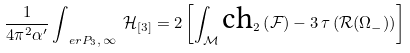Convert formula to latex. <formula><loc_0><loc_0><loc_500><loc_500>\frac { 1 } { 4 \pi ^ { 2 } \alpha ^ { \prime } } \int _ { \ e r P _ { 3 } , \, \infty } \, \mathcal { H } _ { [ 3 ] } = 2 \left [ \int _ { \mathcal { M } } \text {ch} _ { 2 } \left ( \mathcal { F } \right ) - 3 \, \tau \left ( \mathcal { R } ( \Omega _ { - } ) \right ) \right ]</formula> 